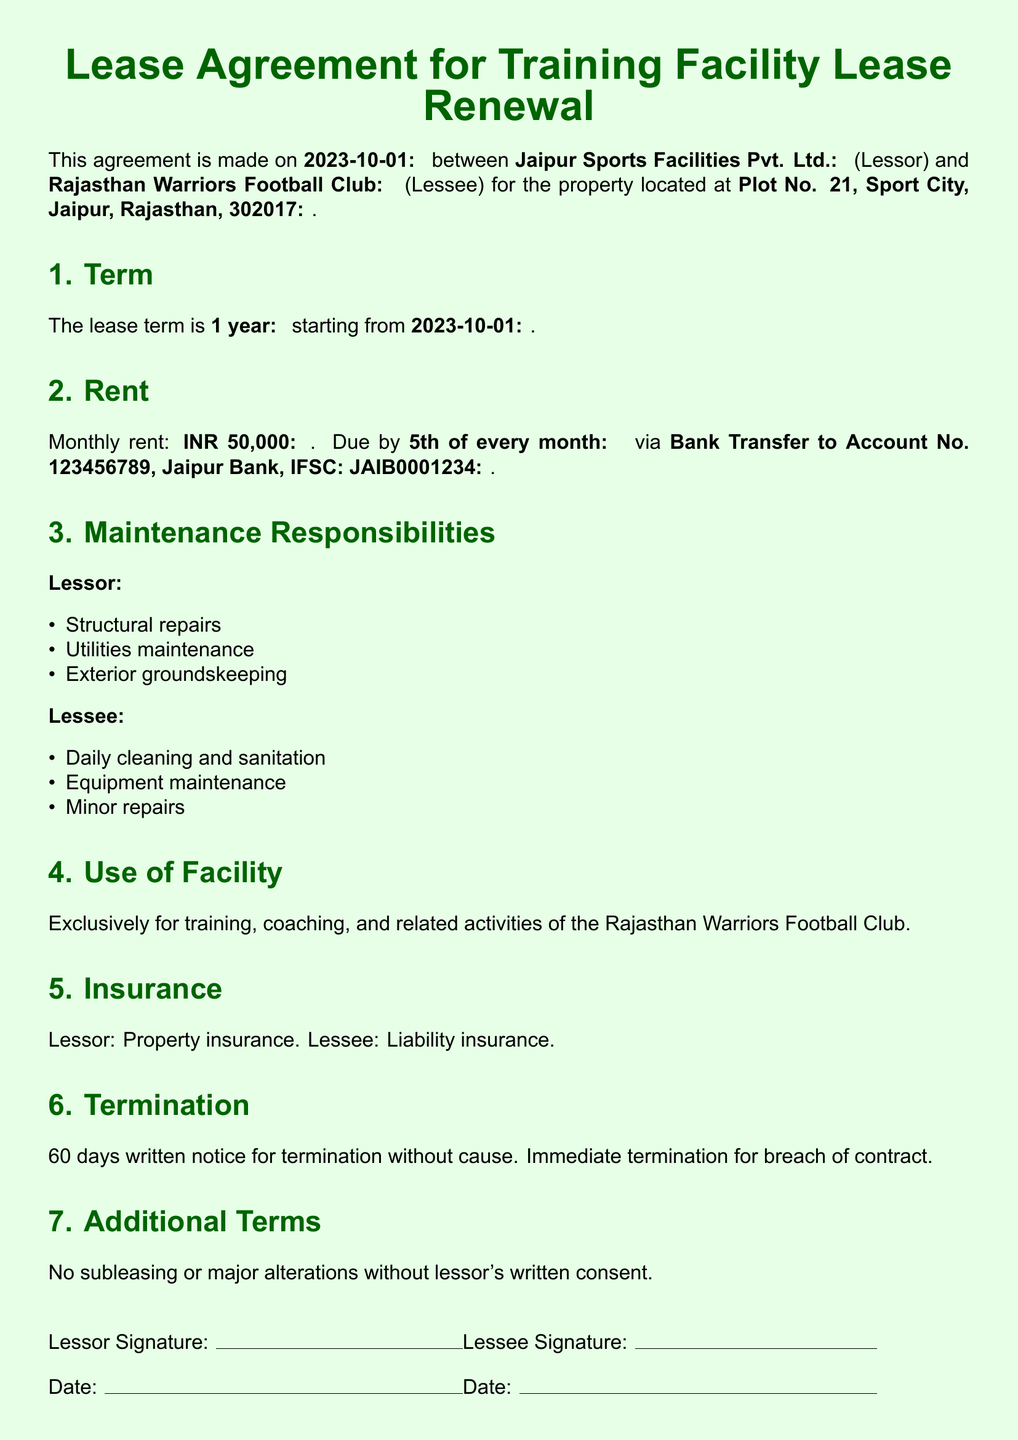What is the lease start date? The lease start date is explicitly mentioned in the document.
Answer: 2023-10-01 What is the monthly rent amount? The monthly rent amount is specified in the lease agreement.
Answer: INR 50,000 Who is the lessor in this agreement? The document states who the lessor is.
Answer: Jaipur Sports Facilities Pvt. Ltd What is the termination notice period? The agreement details the notice period required for termination.
Answer: 60 days What maintenance responsibility does the lessee have? The document outlines specific maintenance responsibilities assigned to the lessee.
Answer: Daily cleaning and sanitation What is the duration of the lease? The duration of the lease term is explicitly stated in the document.
Answer: 1 year What is required for immediate termination? The conditions for immediate termination are clearly outlined in the document.
Answer: Breach of contract What type of insurance does the lessee need? The document specifies the type of insurance required for the lessee.
Answer: Liability insurance Are subleasing and major alterations allowed? The lease agreement mentions restrictions on subleasing and alterations.
Answer: No 